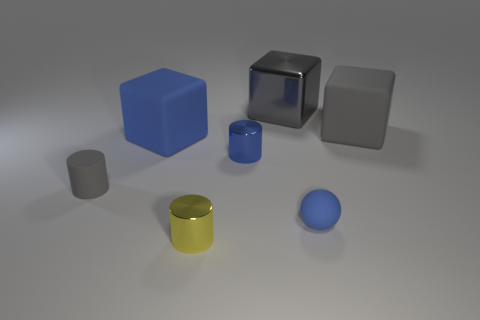Subtract all red spheres. How many gray cubes are left? 2 Subtract all metal cylinders. How many cylinders are left? 1 Add 1 purple objects. How many objects exist? 8 Subtract all cylinders. How many objects are left? 4 Subtract all green metallic cubes. Subtract all tiny gray rubber cylinders. How many objects are left? 6 Add 5 big gray rubber things. How many big gray rubber things are left? 6 Add 5 large cyan metallic balls. How many large cyan metallic balls exist? 5 Subtract 0 purple blocks. How many objects are left? 7 